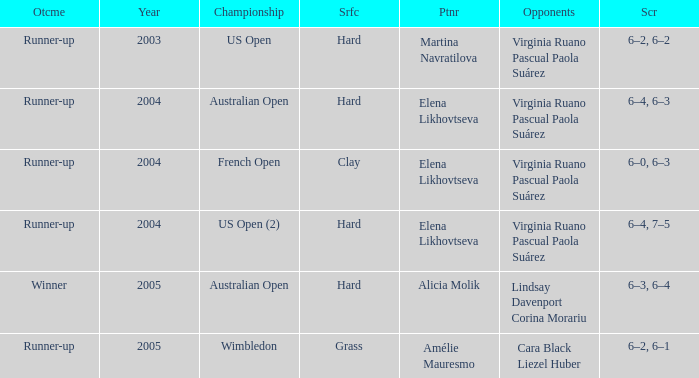When us open (2) is the championship what is the surface? Hard. 